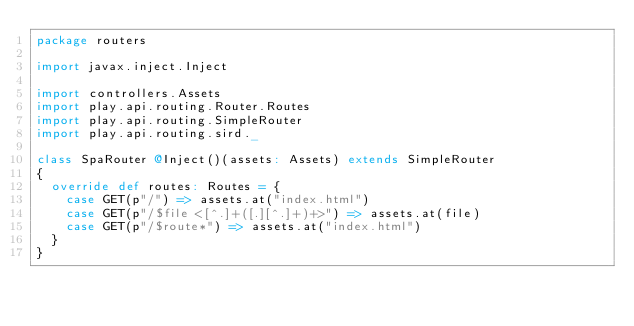Convert code to text. <code><loc_0><loc_0><loc_500><loc_500><_Scala_>package routers

import javax.inject.Inject

import controllers.Assets
import play.api.routing.Router.Routes
import play.api.routing.SimpleRouter
import play.api.routing.sird._

class SpaRouter @Inject()(assets: Assets) extends SimpleRouter
{
  override def routes: Routes = {
    case GET(p"/") => assets.at("index.html")
    case GET(p"/$file<[^.]+([.][^.]+)+>") => assets.at(file)
    case GET(p"/$route*") => assets.at("index.html")
  }
}
</code> 